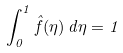Convert formula to latex. <formula><loc_0><loc_0><loc_500><loc_500>\int _ { 0 } ^ { 1 } \hat { f } ( \eta ) \, d \eta = 1</formula> 